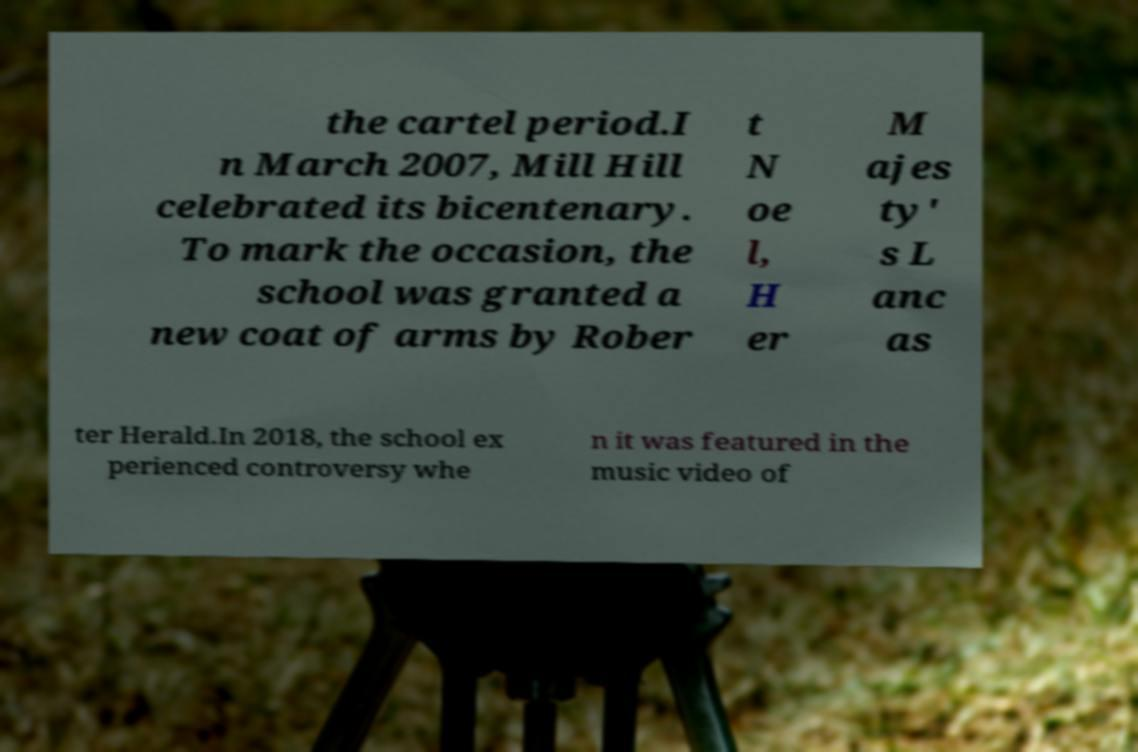There's text embedded in this image that I need extracted. Can you transcribe it verbatim? the cartel period.I n March 2007, Mill Hill celebrated its bicentenary. To mark the occasion, the school was granted a new coat of arms by Rober t N oe l, H er M ajes ty' s L anc as ter Herald.In 2018, the school ex perienced controversy whe n it was featured in the music video of 